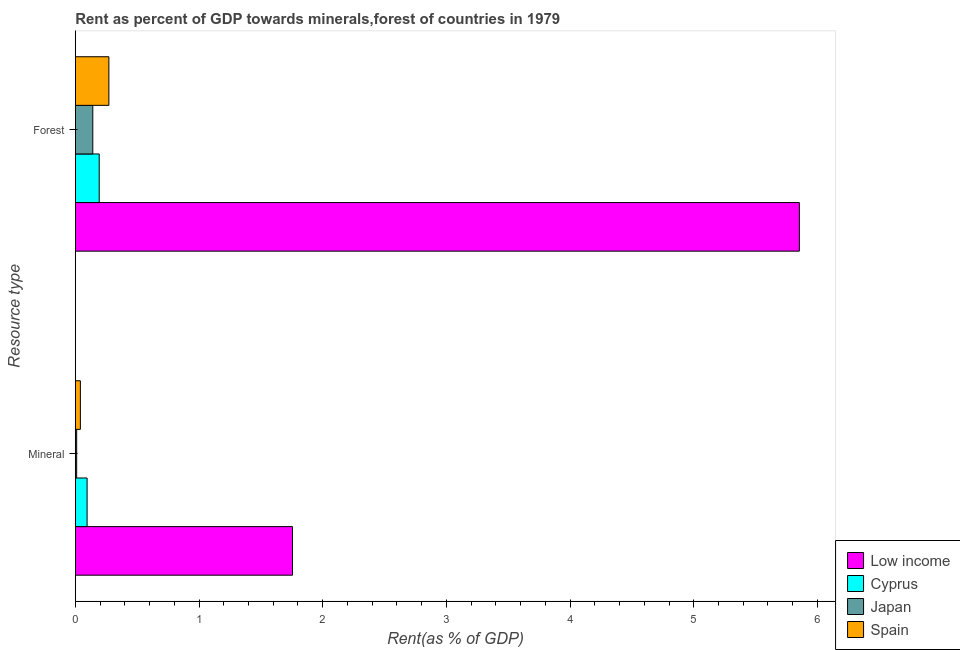How many different coloured bars are there?
Provide a succinct answer. 4. How many groups of bars are there?
Keep it short and to the point. 2. Are the number of bars on each tick of the Y-axis equal?
Give a very brief answer. Yes. How many bars are there on the 1st tick from the top?
Provide a succinct answer. 4. What is the label of the 1st group of bars from the top?
Provide a short and direct response. Forest. What is the mineral rent in Cyprus?
Your response must be concise. 0.1. Across all countries, what is the maximum forest rent?
Make the answer very short. 5.85. Across all countries, what is the minimum forest rent?
Offer a very short reply. 0.14. What is the total mineral rent in the graph?
Provide a succinct answer. 1.9. What is the difference between the mineral rent in Spain and that in Low income?
Your answer should be compact. -1.72. What is the difference between the forest rent in Cyprus and the mineral rent in Low income?
Your response must be concise. -1.56. What is the average forest rent per country?
Your response must be concise. 1.61. What is the difference between the forest rent and mineral rent in Low income?
Give a very brief answer. 4.1. What is the ratio of the mineral rent in Low income to that in Spain?
Your answer should be very brief. 42.78. What does the 3rd bar from the top in Forest represents?
Make the answer very short. Cyprus. What does the 4th bar from the bottom in Forest represents?
Provide a succinct answer. Spain. How many bars are there?
Keep it short and to the point. 8. What is the difference between two consecutive major ticks on the X-axis?
Make the answer very short. 1. Does the graph contain any zero values?
Ensure brevity in your answer.  No. Does the graph contain grids?
Ensure brevity in your answer.  No. How many legend labels are there?
Give a very brief answer. 4. What is the title of the graph?
Your answer should be very brief. Rent as percent of GDP towards minerals,forest of countries in 1979. Does "Gabon" appear as one of the legend labels in the graph?
Your answer should be very brief. No. What is the label or title of the X-axis?
Offer a very short reply. Rent(as % of GDP). What is the label or title of the Y-axis?
Keep it short and to the point. Resource type. What is the Rent(as % of GDP) in Low income in Mineral?
Ensure brevity in your answer.  1.76. What is the Rent(as % of GDP) in Cyprus in Mineral?
Your response must be concise. 0.1. What is the Rent(as % of GDP) in Japan in Mineral?
Your answer should be very brief. 0.01. What is the Rent(as % of GDP) of Spain in Mineral?
Your answer should be very brief. 0.04. What is the Rent(as % of GDP) of Low income in Forest?
Offer a very short reply. 5.85. What is the Rent(as % of GDP) of Cyprus in Forest?
Your response must be concise. 0.19. What is the Rent(as % of GDP) of Japan in Forest?
Keep it short and to the point. 0.14. What is the Rent(as % of GDP) in Spain in Forest?
Give a very brief answer. 0.27. Across all Resource type, what is the maximum Rent(as % of GDP) in Low income?
Ensure brevity in your answer.  5.85. Across all Resource type, what is the maximum Rent(as % of GDP) in Cyprus?
Keep it short and to the point. 0.19. Across all Resource type, what is the maximum Rent(as % of GDP) of Japan?
Make the answer very short. 0.14. Across all Resource type, what is the maximum Rent(as % of GDP) of Spain?
Offer a terse response. 0.27. Across all Resource type, what is the minimum Rent(as % of GDP) of Low income?
Provide a short and direct response. 1.76. Across all Resource type, what is the minimum Rent(as % of GDP) of Cyprus?
Give a very brief answer. 0.1. Across all Resource type, what is the minimum Rent(as % of GDP) of Japan?
Offer a very short reply. 0.01. Across all Resource type, what is the minimum Rent(as % of GDP) in Spain?
Provide a succinct answer. 0.04. What is the total Rent(as % of GDP) in Low income in the graph?
Make the answer very short. 7.61. What is the total Rent(as % of GDP) of Cyprus in the graph?
Your answer should be very brief. 0.29. What is the total Rent(as % of GDP) of Japan in the graph?
Provide a short and direct response. 0.15. What is the total Rent(as % of GDP) in Spain in the graph?
Offer a terse response. 0.31. What is the difference between the Rent(as % of GDP) in Low income in Mineral and that in Forest?
Ensure brevity in your answer.  -4.1. What is the difference between the Rent(as % of GDP) of Cyprus in Mineral and that in Forest?
Provide a short and direct response. -0.1. What is the difference between the Rent(as % of GDP) in Japan in Mineral and that in Forest?
Make the answer very short. -0.13. What is the difference between the Rent(as % of GDP) of Spain in Mineral and that in Forest?
Offer a terse response. -0.23. What is the difference between the Rent(as % of GDP) of Low income in Mineral and the Rent(as % of GDP) of Cyprus in Forest?
Make the answer very short. 1.56. What is the difference between the Rent(as % of GDP) of Low income in Mineral and the Rent(as % of GDP) of Japan in Forest?
Offer a very short reply. 1.61. What is the difference between the Rent(as % of GDP) in Low income in Mineral and the Rent(as % of GDP) in Spain in Forest?
Provide a succinct answer. 1.48. What is the difference between the Rent(as % of GDP) in Cyprus in Mineral and the Rent(as % of GDP) in Japan in Forest?
Offer a terse response. -0.05. What is the difference between the Rent(as % of GDP) of Cyprus in Mineral and the Rent(as % of GDP) of Spain in Forest?
Provide a succinct answer. -0.18. What is the difference between the Rent(as % of GDP) in Japan in Mineral and the Rent(as % of GDP) in Spain in Forest?
Give a very brief answer. -0.26. What is the average Rent(as % of GDP) of Low income per Resource type?
Offer a very short reply. 3.8. What is the average Rent(as % of GDP) in Cyprus per Resource type?
Offer a terse response. 0.14. What is the average Rent(as % of GDP) of Japan per Resource type?
Ensure brevity in your answer.  0.08. What is the average Rent(as % of GDP) of Spain per Resource type?
Offer a very short reply. 0.16. What is the difference between the Rent(as % of GDP) in Low income and Rent(as % of GDP) in Cyprus in Mineral?
Provide a succinct answer. 1.66. What is the difference between the Rent(as % of GDP) of Low income and Rent(as % of GDP) of Japan in Mineral?
Ensure brevity in your answer.  1.75. What is the difference between the Rent(as % of GDP) of Low income and Rent(as % of GDP) of Spain in Mineral?
Offer a very short reply. 1.72. What is the difference between the Rent(as % of GDP) of Cyprus and Rent(as % of GDP) of Japan in Mineral?
Offer a terse response. 0.08. What is the difference between the Rent(as % of GDP) of Cyprus and Rent(as % of GDP) of Spain in Mineral?
Offer a very short reply. 0.05. What is the difference between the Rent(as % of GDP) of Japan and Rent(as % of GDP) of Spain in Mineral?
Provide a succinct answer. -0.03. What is the difference between the Rent(as % of GDP) of Low income and Rent(as % of GDP) of Cyprus in Forest?
Your answer should be compact. 5.66. What is the difference between the Rent(as % of GDP) of Low income and Rent(as % of GDP) of Japan in Forest?
Give a very brief answer. 5.71. What is the difference between the Rent(as % of GDP) of Low income and Rent(as % of GDP) of Spain in Forest?
Keep it short and to the point. 5.58. What is the difference between the Rent(as % of GDP) of Cyprus and Rent(as % of GDP) of Japan in Forest?
Ensure brevity in your answer.  0.05. What is the difference between the Rent(as % of GDP) in Cyprus and Rent(as % of GDP) in Spain in Forest?
Make the answer very short. -0.08. What is the difference between the Rent(as % of GDP) in Japan and Rent(as % of GDP) in Spain in Forest?
Your answer should be compact. -0.13. What is the ratio of the Rent(as % of GDP) of Low income in Mineral to that in Forest?
Ensure brevity in your answer.  0.3. What is the ratio of the Rent(as % of GDP) of Cyprus in Mineral to that in Forest?
Ensure brevity in your answer.  0.49. What is the ratio of the Rent(as % of GDP) of Japan in Mineral to that in Forest?
Offer a very short reply. 0.08. What is the ratio of the Rent(as % of GDP) of Spain in Mineral to that in Forest?
Your answer should be compact. 0.15. What is the difference between the highest and the second highest Rent(as % of GDP) in Low income?
Offer a terse response. 4.1. What is the difference between the highest and the second highest Rent(as % of GDP) of Cyprus?
Your answer should be compact. 0.1. What is the difference between the highest and the second highest Rent(as % of GDP) of Japan?
Offer a terse response. 0.13. What is the difference between the highest and the second highest Rent(as % of GDP) in Spain?
Your response must be concise. 0.23. What is the difference between the highest and the lowest Rent(as % of GDP) in Low income?
Your answer should be compact. 4.1. What is the difference between the highest and the lowest Rent(as % of GDP) of Cyprus?
Make the answer very short. 0.1. What is the difference between the highest and the lowest Rent(as % of GDP) in Japan?
Offer a very short reply. 0.13. What is the difference between the highest and the lowest Rent(as % of GDP) in Spain?
Your answer should be compact. 0.23. 